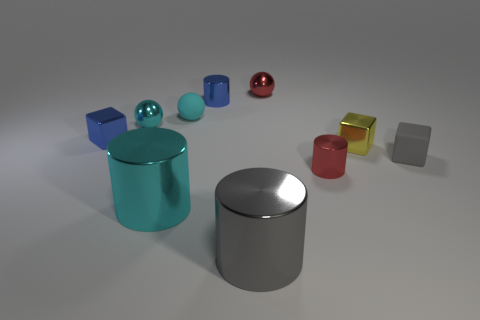Subtract all blue cylinders. How many cyan spheres are left? 2 Subtract all blue metallic cylinders. How many cylinders are left? 3 Subtract 1 balls. How many balls are left? 2 Subtract all gray cylinders. How many cylinders are left? 3 Subtract all cubes. How many objects are left? 7 Add 5 red metallic balls. How many red metallic balls exist? 6 Subtract 0 brown blocks. How many objects are left? 10 Subtract all red cubes. Subtract all red cylinders. How many cubes are left? 3 Subtract all gray things. Subtract all small cylinders. How many objects are left? 6 Add 9 tiny cyan shiny objects. How many tiny cyan shiny objects are left? 10 